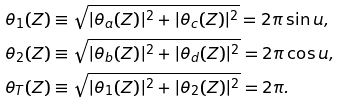Convert formula to latex. <formula><loc_0><loc_0><loc_500><loc_500>\theta _ { 1 } ( Z ) & \equiv \sqrt { | \theta _ { a } ( Z ) | ^ { 2 } + | \theta _ { c } ( Z ) | ^ { 2 } } = 2 \pi \sin u , \\ \theta _ { 2 } ( Z ) & \equiv \sqrt { | \theta _ { b } ( Z ) | ^ { 2 } + | \theta _ { d } ( Z ) | ^ { 2 } } = 2 \pi \cos u , \\ \theta _ { T } ( Z ) & \equiv \sqrt { | \theta _ { 1 } ( Z ) | ^ { 2 } + | \theta _ { 2 } ( Z ) | ^ { 2 } } = 2 \pi .</formula> 